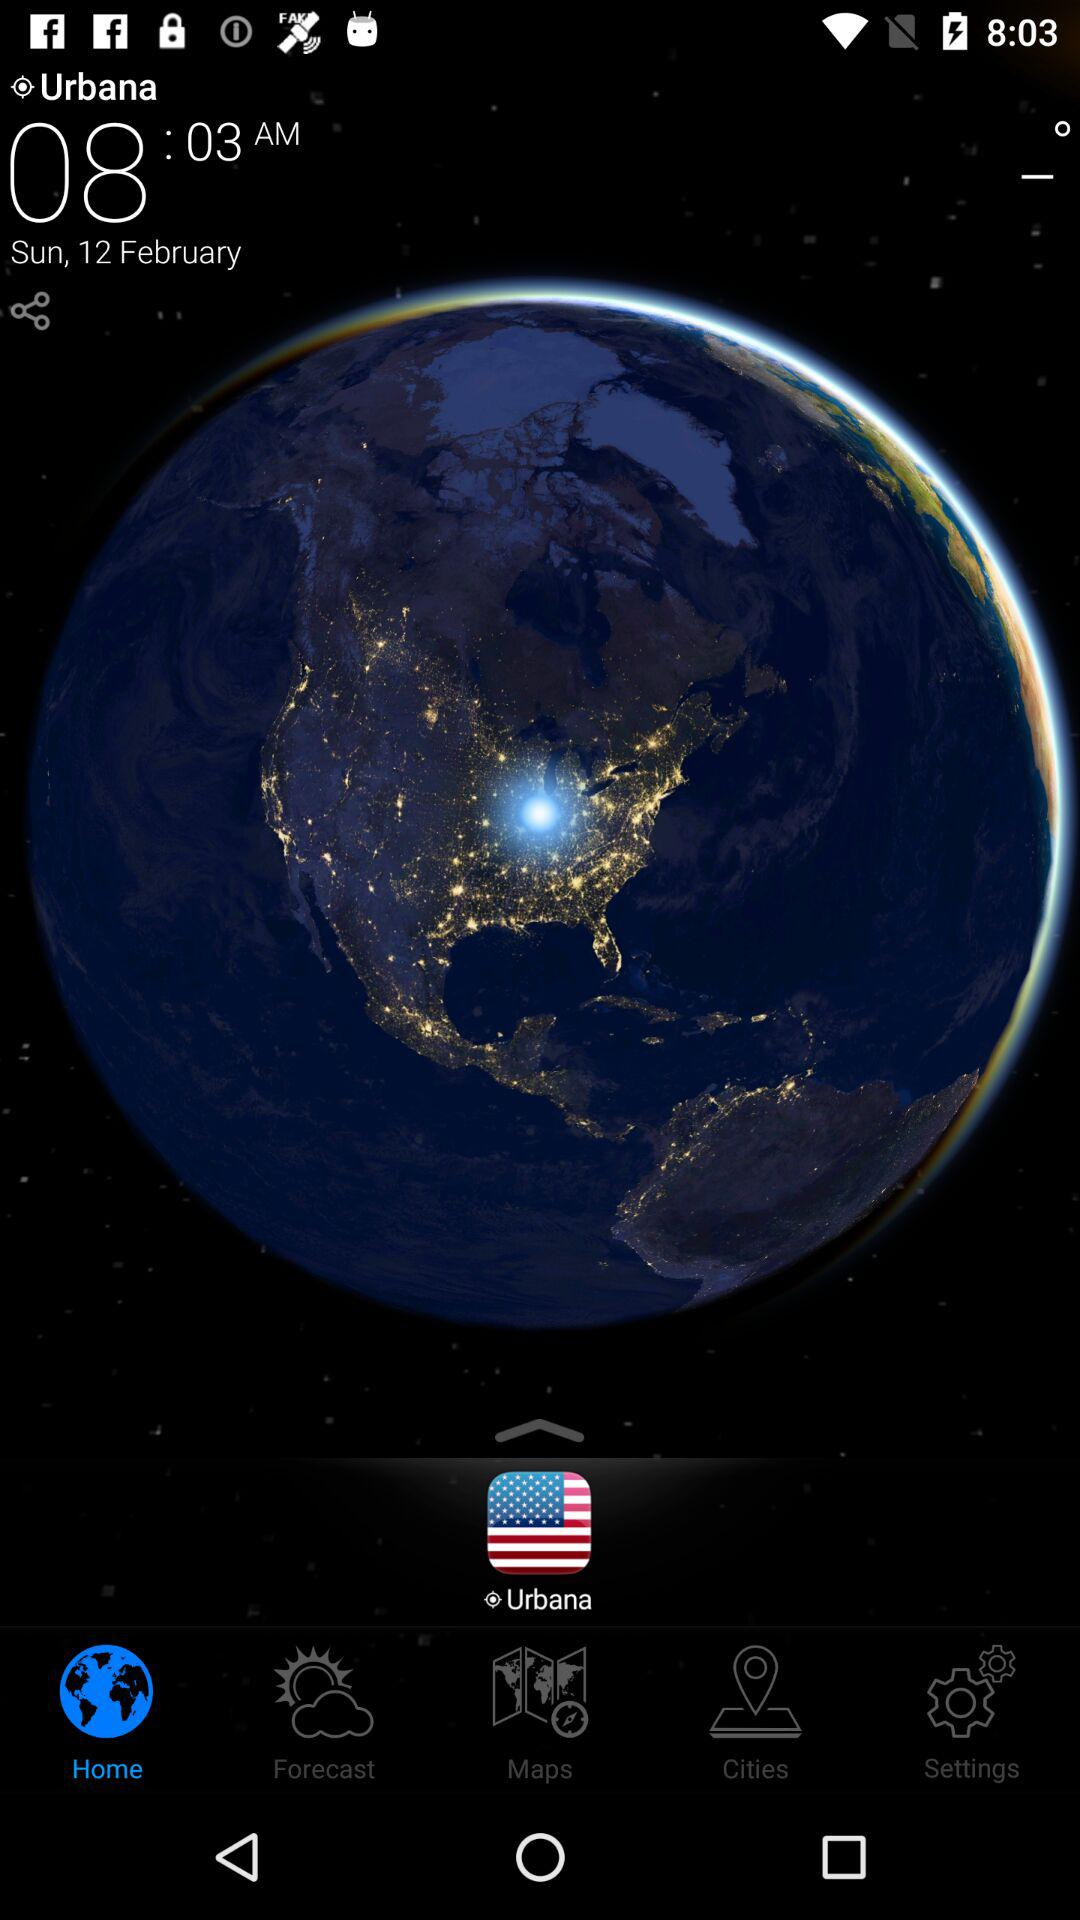What is the time? The time is 08:03 AM. 